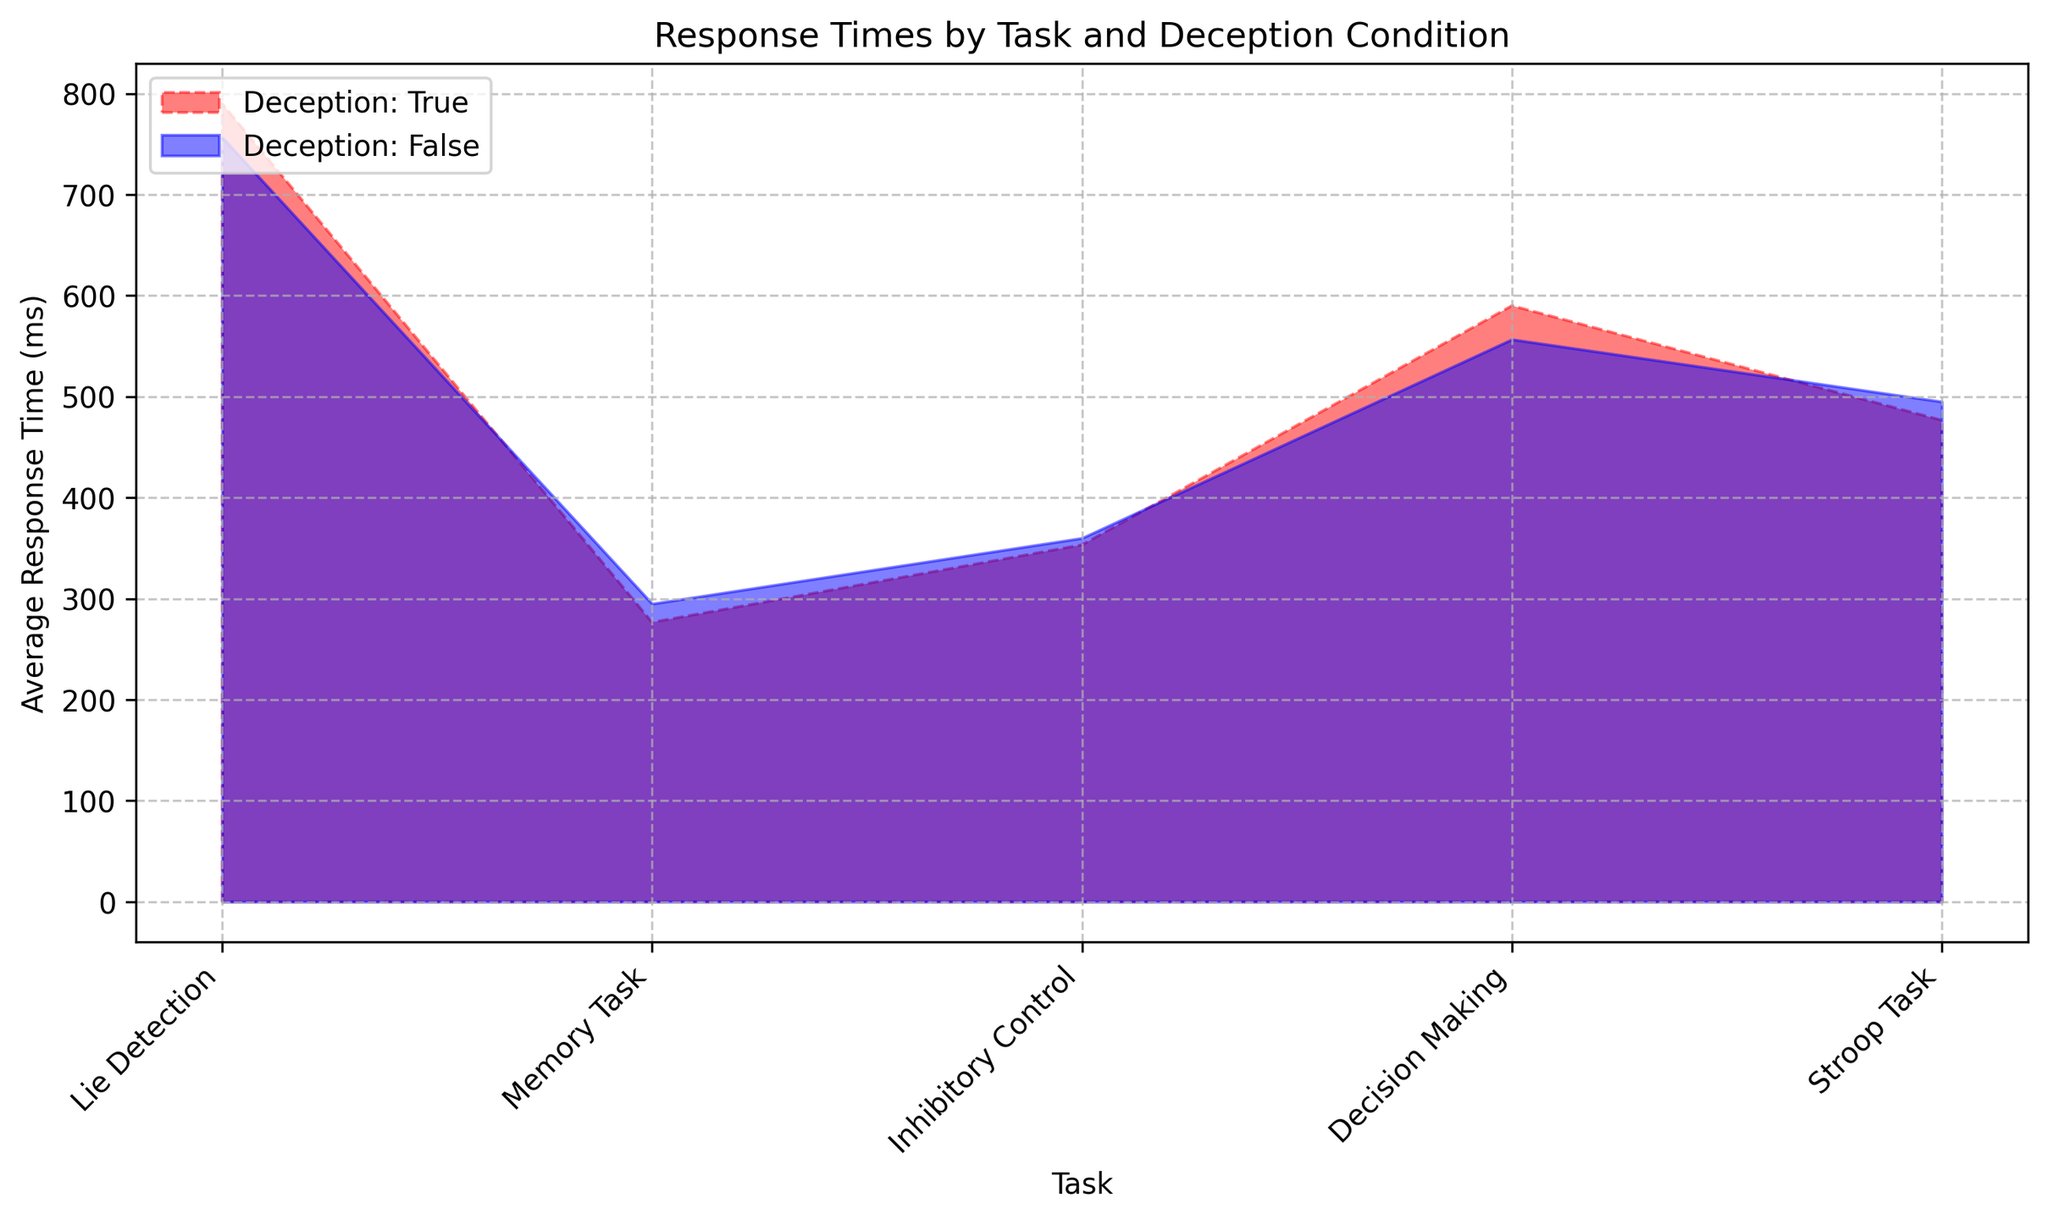What is the average response time for the Lie Detection task under deception? To find this answer, locate the area for the Lie Detection task under the condition where deception is true (red, dashed line). Average the response times for Lie Detection tasks marked as true: (300 + 350 + 410) / 3
Answer: 353.33 ms How does the average response time differ between deceptive and non-deceptive conditions for the Decision Making task? First, find the average response times for both conditions in the Decision Making task. For deception (true), it’s (800 + 780) / 2 = 790 ms. For non-deception (false), it’s (700 + 750 + 820) / 3 ≈ 756.67 ms. Then, calculate the difference: 790 - 756.67
Answer: 33.33 ms Which task shows the greatest difference in average response time between deceptive and non-deceptive conditions? Compare the average response times for all tasks under both conditions:
- Lie Detection: 353.33 ms (True) vs. 360 ms (False) => 6.67 ms
- Memory Task: 580 ms (True) vs. 556.67 ms (False) => 23.33 ms
- Inhibitory Control: 276.67 ms (True) vs. 295 ms (False) => 18.33 ms
- Decision Making: 790 ms (True) vs. 756.67 ms (False) => 33.33 ms
- Stroop Task: 476.67 ms (True) vs. 496.67 ms (False) => 20 ms
The Decision Making task has the greatest difference.
Answer: Decision Making Which condition shows higher average response times across all tasks? Calculate the average response times across all tasks per condition:
- Deception (True): (353.33 + 580 + 276.67 + 790 + 476.67) / 5 ≈ 495.73 ms
- Non-Deception (False): (360 + 556.67 + 295 + 756.67 + 496.67) / 5 ≈ 493.4 ms
Compare the averages: 495.73 ms is slightly higher than 493.4 ms.
Answer: Deception In which task is the average response time under non-deceptive conditions the lowest? Compare the average response times under non-deceptive conditions for each task:
- Lie Detection: 360 ms
- Memory Task: 556.67 ms
- Inhibitory Control: 295 ms
- Decision Making: 756.67 ms
- Stroop Task: 496.67 ms
The Inhibitory Control task has the lowest average response time.
Answer: Inhibitory Control What is the visual distinction between the areas representing deceptive and non-deceptive conditions? The deceptive condition is represented by a red, dashed line, while the non-deceptive condition is represented by a blue, solid line. The fill between tasks shows the different shaded areas for each condition.
Answer: Red dashed vs. blue solid Which task has the most consistent (smallest range of) response times when averaged across both conditions? To find this, compare the range (difference between maximum and minimum) of response times averaged across both conditions for each task:
- Lie Detection: 360 - 353.33 = 6.67 ms
- Memory Task: 580 - 556.67 = 23.33 ms
- Inhibitory Control: 295 - 276.67 = 18.33 ms
- Decision Making: 790 - 756.67 = 33.33 ms
- Stroop Task: 496.67 - 476.67 = 20 ms
The Lie Detection task has the smallest range.
Answer: Lie Detection 